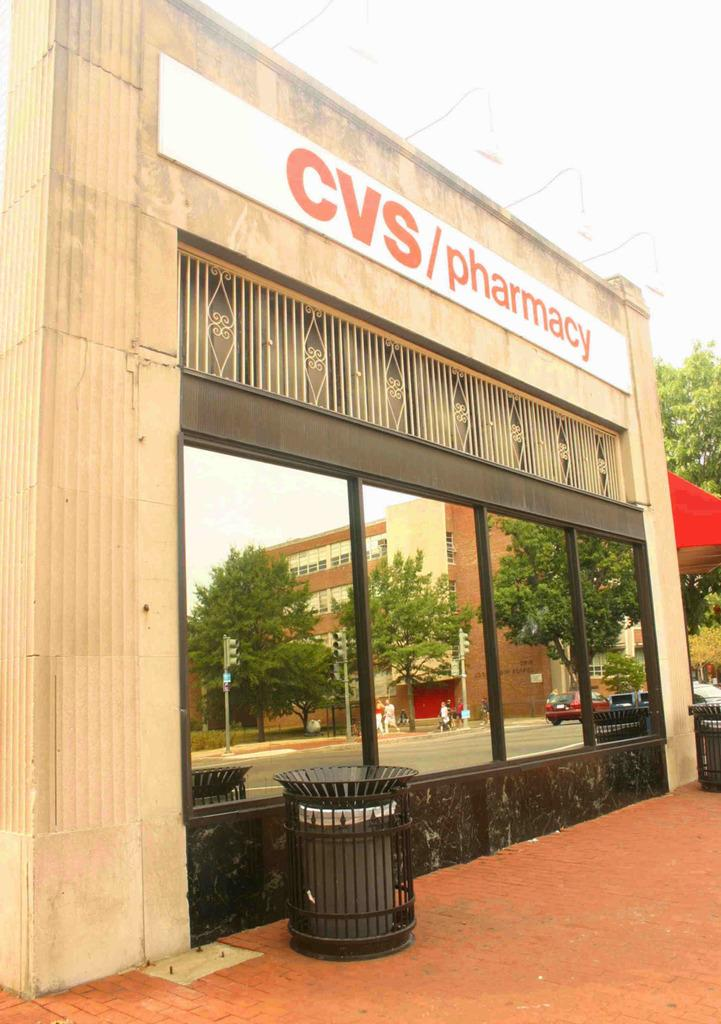<image>
Present a compact description of the photo's key features. the outside of a building with a sign that says 'cvs/pharmacy' on it 